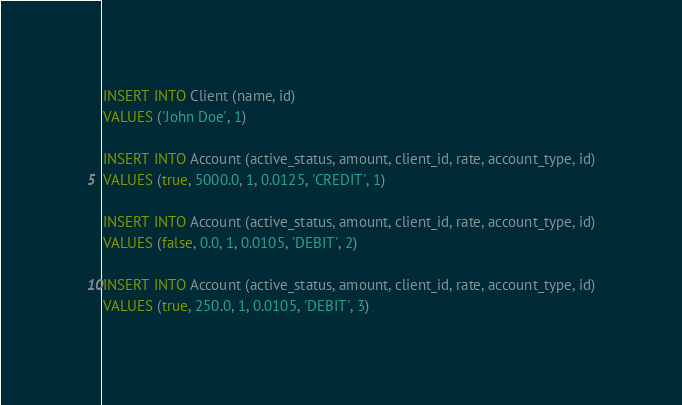<code> <loc_0><loc_0><loc_500><loc_500><_SQL_>INSERT INTO Client (name, id)
VALUES ('John Doe', 1)

INSERT INTO Account (active_status, amount, client_id, rate, account_type, id)
VALUES (true, 5000.0, 1, 0.0125, 'CREDIT', 1)

INSERT INTO Account (active_status, amount, client_id, rate, account_type, id)
VALUES (false, 0.0, 1, 0.0105, 'DEBIT', 2)

INSERT INTO Account (active_status, amount, client_id, rate, account_type, id)
VALUES (true, 250.0, 1, 0.0105, 'DEBIT', 3)</code> 